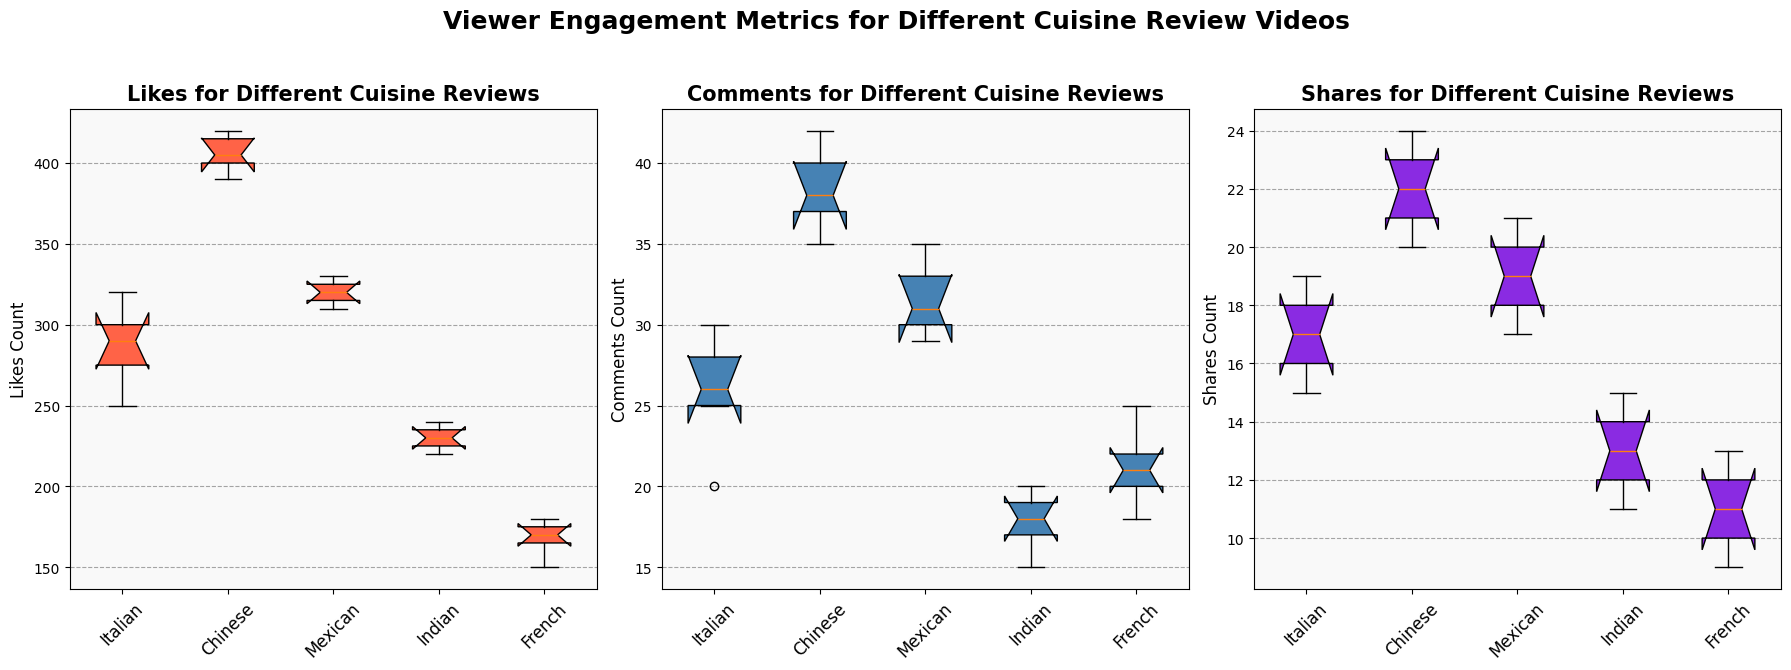Which cuisine has the highest median number of likes? To determine the median number of likes, look at the likes box plot and locate the middle value of the data set. The Chinese cuisine box plot for likes is the highest among all cuisines, indicating the highest median value.
Answer: Chinese Which cuisine has the greatest variation in comments? Variation in the comments can be assessed by looking at the interquartile range (IQR), which is the length of the box in the box plot. The Chinese cuisine comments plot shows the largest IQR, indicating the greatest variation.
Answer: Chinese Compare the median shares between Italian and Mexican cuisine. Which one is higher? To compare the median shares, look at the median line within each box for the Italian and Mexican cuisines in the shares plot. The median line for Mexican cuisine is higher than that of Italian cuisine.
Answer: Mexican What is the range of likes for French cuisine? To find the range, subtract the minimum value from the maximum value in the French likes box plot. Visually, the small whiskers at the bottom and top of the box indicate the minimum and maximum values respectively. The range is 180 - 150 = 30.
Answer: 30 Do Indian cuisine reviews get more comments or shares on average? Compare the median lines within the Indian cuisine boxes in the comments and shares plots. The median line for comments is higher than that for shares, indicating that comments are more prevalent.
Answer: Comments Which cuisine shows the least variation in shares? The least variation can be identified by the smallest IQR, the length of the box, in the shares plot. Indian cuisine has the smallest IQR for shares, indicating the least variation.
Answer: Indian How does the engagement (likes, comments, shares) of Italian cuisine compare to Mexican cuisine? Compare all three metrics across the Italian and Mexican cuisine box plots. Italian cuisine shows lower median likes but comparable comments and slightly lower shares compared to Mexican cuisine.
Answer: Lower likes, similar comments, and lower shares Which two cuisines have the closest median number of comments? Look at the comments box plot and compare the median lines. Italian and French cuisines have median lines that are very close to each other at around 25 for comments.
Answer: Italian and French What can be said about the consistency of viewer engagement for Chinese cuisine? For Chinese cuisine, the likes, comments, and shares box plots have notable heights in their boxes and whiskers, indicating a higher range and greater variation but also high engagement levels. All medians are relatively high compared to other cuisines.
Answer: High variation and engagement 